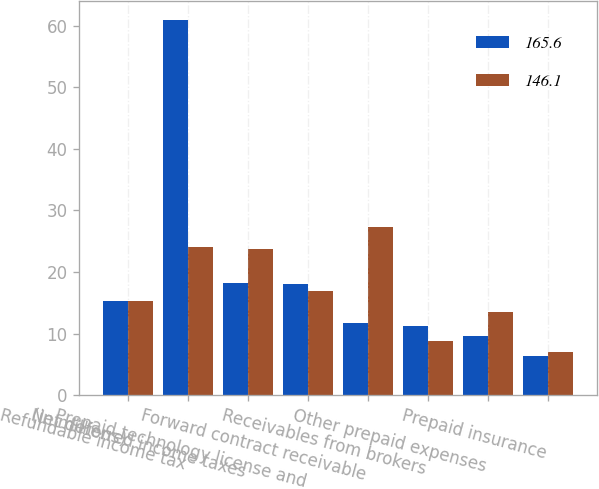Convert chart to OTSL. <chart><loc_0><loc_0><loc_500><loc_500><stacked_bar_chart><ecel><fcel>(in millions)<fcel>Refundable income tax<fcel>Net deferred income taxes<fcel>Prepaid technology license and<fcel>Forward contract receivable<fcel>Receivables from brokers<fcel>Other prepaid expenses<fcel>Prepaid insurance<nl><fcel>165.6<fcel>15.25<fcel>61<fcel>18.3<fcel>18<fcel>11.8<fcel>11.2<fcel>9.6<fcel>6.3<nl><fcel>146.1<fcel>15.25<fcel>24.1<fcel>23.8<fcel>17<fcel>27.3<fcel>8.8<fcel>13.5<fcel>7<nl></chart> 